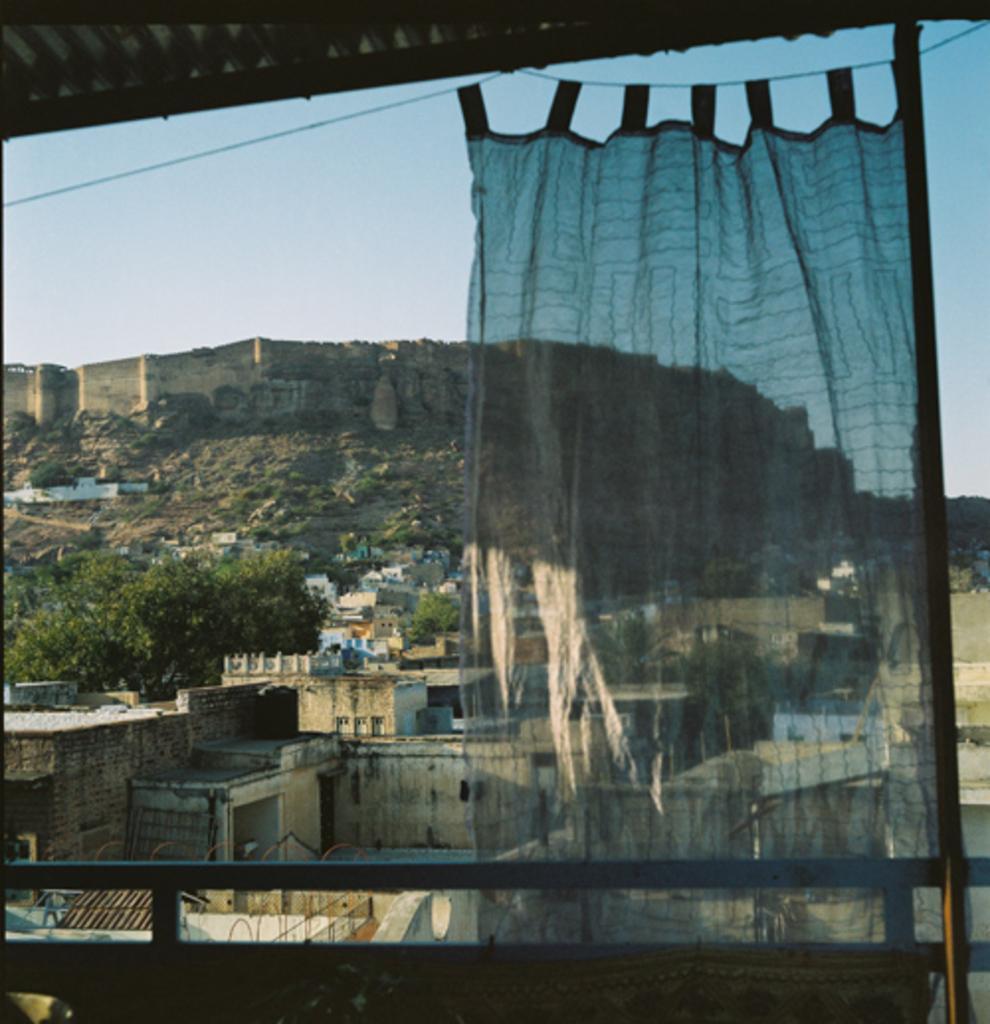In one or two sentences, can you explain what this image depicts? This image consists of many houses. On the left, there is a tree. In the background, we can see a wall. At the top, there is a sky. In the front, there is a curtain in blue color. At the top, there is a shed. At the bottom, we can see a railing. 